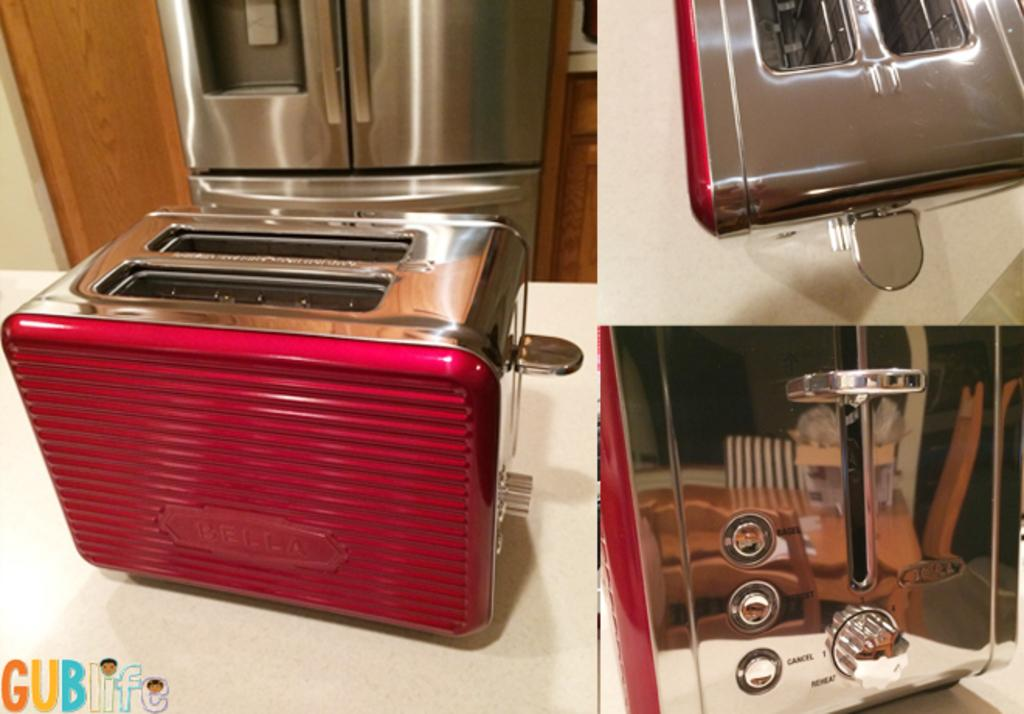What appliances can be seen on the surface in the image? There are toasters on a surface in the image. Can you identify any other kitchen appliances in the image? A microwave oven is partially visible in the image. What is located in the left corner of the image? There is text in the left corner of the image. How many hands are visible in the image? There are no hands visible in the image. What type of eggs are being prepared in the image? There is no indication of eggs or any food preparation in the image. 